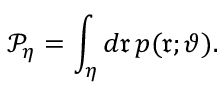<formula> <loc_0><loc_0><loc_500><loc_500>\mathcal { P } _ { \eta } = \int _ { \eta } d \mathfrak { r } \, p ( \mathfrak { r } ; \vartheta ) .</formula> 